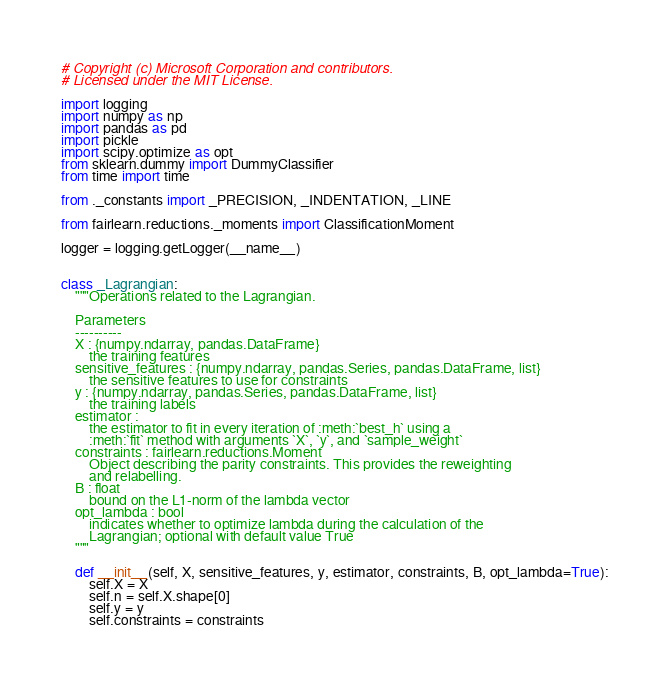Convert code to text. <code><loc_0><loc_0><loc_500><loc_500><_Python_># Copyright (c) Microsoft Corporation and contributors.
# Licensed under the MIT License.

import logging
import numpy as np
import pandas as pd
import pickle
import scipy.optimize as opt
from sklearn.dummy import DummyClassifier
from time import time

from ._constants import _PRECISION, _INDENTATION, _LINE

from fairlearn.reductions._moments import ClassificationMoment

logger = logging.getLogger(__name__)


class _Lagrangian:
    """Operations related to the Lagrangian.

    Parameters
    ----------
    X : {numpy.ndarray, pandas.DataFrame}
        the training features
    sensitive_features : {numpy.ndarray, pandas.Series, pandas.DataFrame, list}
        the sensitive features to use for constraints
    y : {numpy.ndarray, pandas.Series, pandas.DataFrame, list}
        the training labels
    estimator :
        the estimator to fit in every iteration of :meth:`best_h` using a
        :meth:`fit` method with arguments `X`, `y`, and `sample_weight`
    constraints : fairlearn.reductions.Moment
        Object describing the parity constraints. This provides the reweighting
        and relabelling.
    B : float
        bound on the L1-norm of the lambda vector
    opt_lambda : bool
        indicates whether to optimize lambda during the calculation of the
        Lagrangian; optional with default value True
    """

    def __init__(self, X, sensitive_features, y, estimator, constraints, B, opt_lambda=True):
        self.X = X
        self.n = self.X.shape[0]
        self.y = y
        self.constraints = constraints</code> 